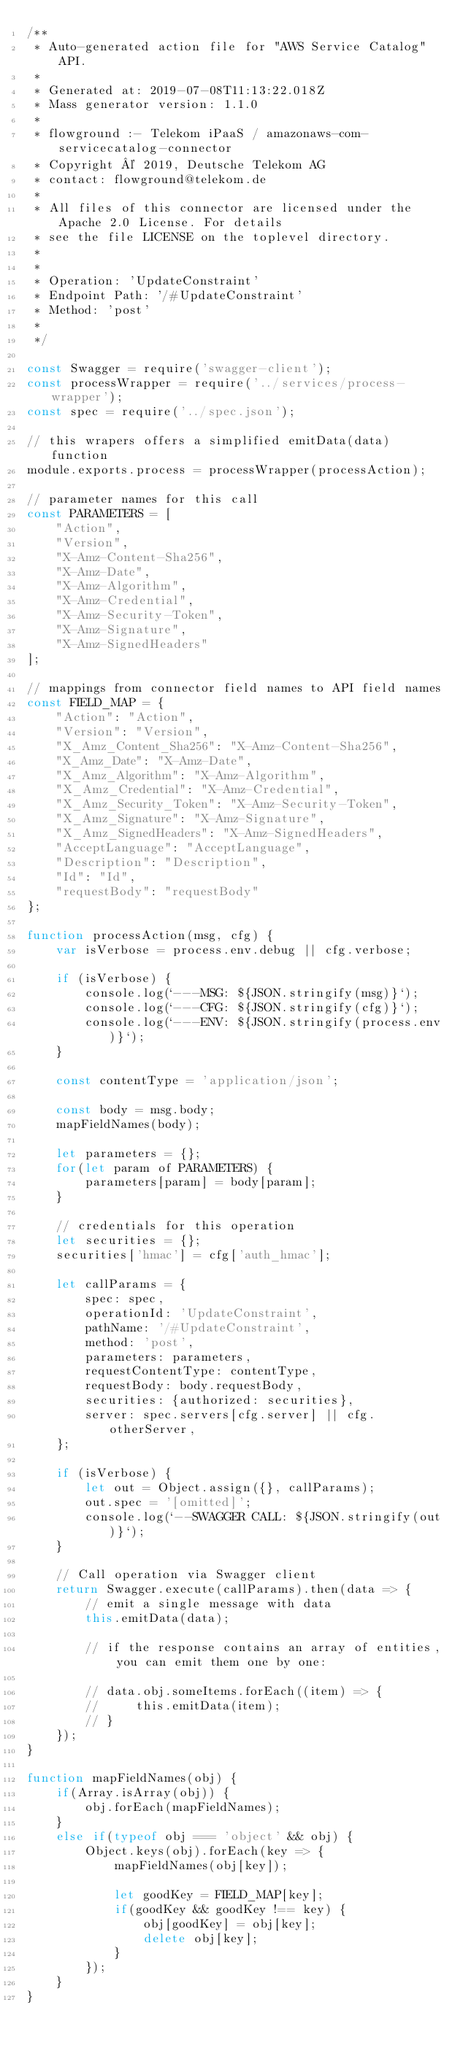Convert code to text. <code><loc_0><loc_0><loc_500><loc_500><_JavaScript_>/**
 * Auto-generated action file for "AWS Service Catalog" API.
 *
 * Generated at: 2019-07-08T11:13:22.018Z
 * Mass generator version: 1.1.0
 *
 * flowground :- Telekom iPaaS / amazonaws-com-servicecatalog-connector
 * Copyright © 2019, Deutsche Telekom AG
 * contact: flowground@telekom.de
 *
 * All files of this connector are licensed under the Apache 2.0 License. For details
 * see the file LICENSE on the toplevel directory.
 *
 *
 * Operation: 'UpdateConstraint'
 * Endpoint Path: '/#UpdateConstraint'
 * Method: 'post'
 *
 */

const Swagger = require('swagger-client');
const processWrapper = require('../services/process-wrapper');
const spec = require('../spec.json');

// this wrapers offers a simplified emitData(data) function
module.exports.process = processWrapper(processAction);

// parameter names for this call
const PARAMETERS = [
    "Action",
    "Version",
    "X-Amz-Content-Sha256",
    "X-Amz-Date",
    "X-Amz-Algorithm",
    "X-Amz-Credential",
    "X-Amz-Security-Token",
    "X-Amz-Signature",
    "X-Amz-SignedHeaders"
];

// mappings from connector field names to API field names
const FIELD_MAP = {
    "Action": "Action",
    "Version": "Version",
    "X_Amz_Content_Sha256": "X-Amz-Content-Sha256",
    "X_Amz_Date": "X-Amz-Date",
    "X_Amz_Algorithm": "X-Amz-Algorithm",
    "X_Amz_Credential": "X-Amz-Credential",
    "X_Amz_Security_Token": "X-Amz-Security-Token",
    "X_Amz_Signature": "X-Amz-Signature",
    "X_Amz_SignedHeaders": "X-Amz-SignedHeaders",
    "AcceptLanguage": "AcceptLanguage",
    "Description": "Description",
    "Id": "Id",
    "requestBody": "requestBody"
};

function processAction(msg, cfg) {
    var isVerbose = process.env.debug || cfg.verbose;

    if (isVerbose) {
        console.log(`---MSG: ${JSON.stringify(msg)}`);
        console.log(`---CFG: ${JSON.stringify(cfg)}`);
        console.log(`---ENV: ${JSON.stringify(process.env)}`);
    }

    const contentType = 'application/json';

    const body = msg.body;
    mapFieldNames(body);

    let parameters = {};
    for(let param of PARAMETERS) {
        parameters[param] = body[param];
    }

    // credentials for this operation
    let securities = {};
    securities['hmac'] = cfg['auth_hmac'];

    let callParams = {
        spec: spec,
        operationId: 'UpdateConstraint',
        pathName: '/#UpdateConstraint',
        method: 'post',
        parameters: parameters,
        requestContentType: contentType,
        requestBody: body.requestBody,
        securities: {authorized: securities},
        server: spec.servers[cfg.server] || cfg.otherServer,
    };

    if (isVerbose) {
        let out = Object.assign({}, callParams);
        out.spec = '[omitted]';
        console.log(`--SWAGGER CALL: ${JSON.stringify(out)}`);
    }

    // Call operation via Swagger client
    return Swagger.execute(callParams).then(data => {
        // emit a single message with data
        this.emitData(data);

        // if the response contains an array of entities, you can emit them one by one:

        // data.obj.someItems.forEach((item) => {
        //     this.emitData(item);
        // }
    });
}

function mapFieldNames(obj) {
    if(Array.isArray(obj)) {
        obj.forEach(mapFieldNames);
    }
    else if(typeof obj === 'object' && obj) {
        Object.keys(obj).forEach(key => {
            mapFieldNames(obj[key]);

            let goodKey = FIELD_MAP[key];
            if(goodKey && goodKey !== key) {
                obj[goodKey] = obj[key];
                delete obj[key];
            }
        });
    }
}</code> 